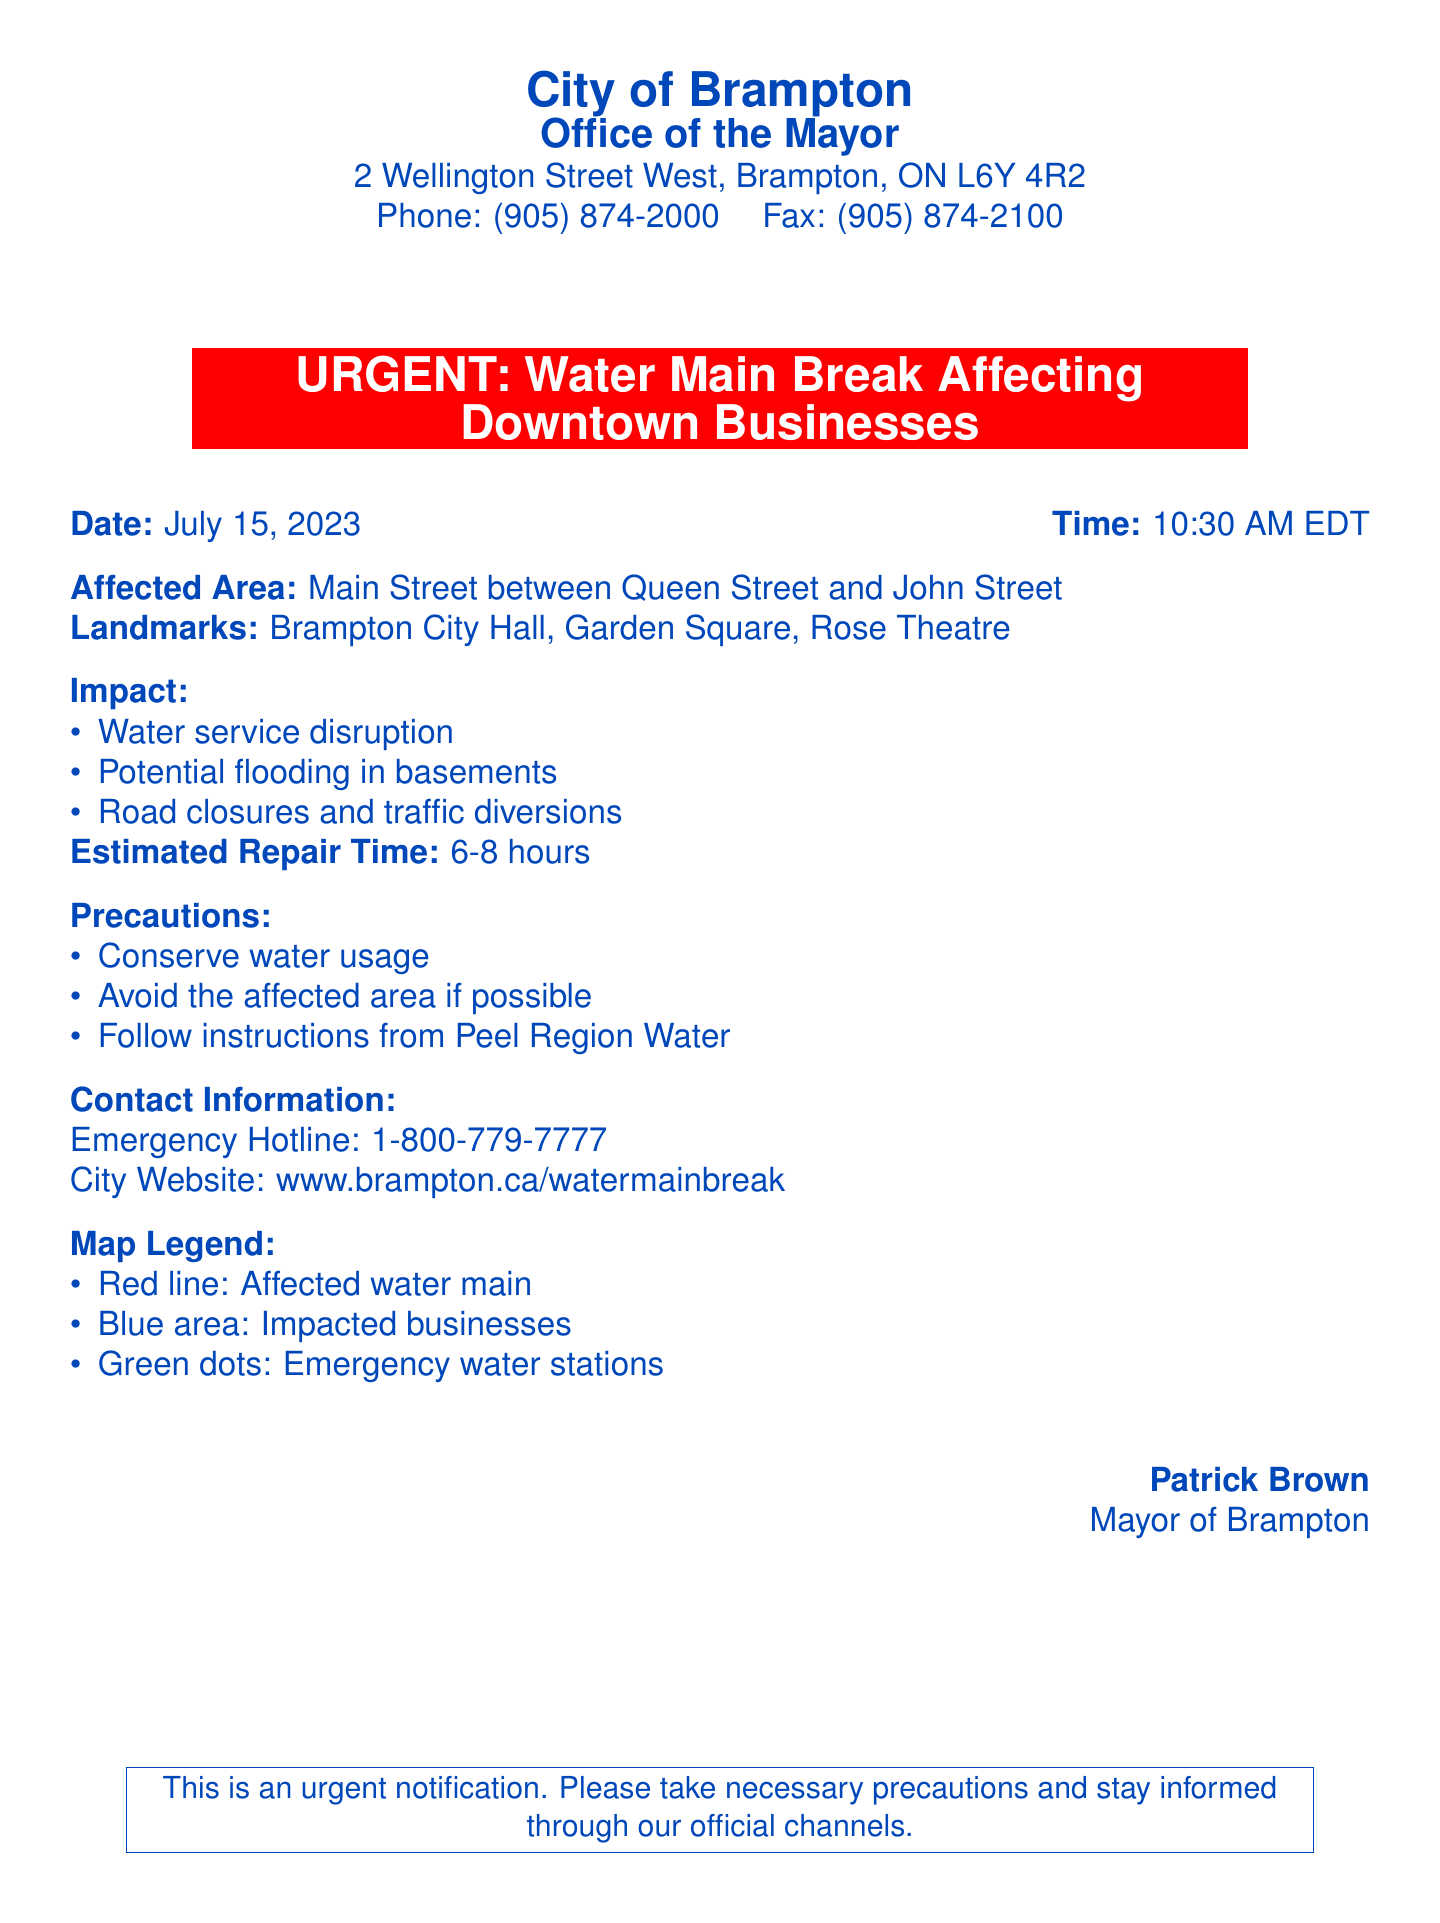What is the date of the water main break notification? The date is specified in the document as July 15, 2023.
Answer: July 15, 2023 What landmarks are mentioned in the affected area? The document lists Brampton City Hall, Garden Square, and Rose Theatre as landmarks.
Answer: Brampton City Hall, Garden Square, Rose Theatre What is the estimated repair time for the water main break? The estimated repair time is given in hours as 6-8 hours.
Answer: 6-8 hours What precautions should residents take? The document outlines precautions such as conserving water usage and avoiding the affected area.
Answer: Conserve water usage, avoid the affected area What is the emergency hotline number? The emergency hotline number is provided in the document for urgent inquiries related to the situation.
Answer: 1-800-779-7777 How will traffic be affected due to the water main break? The document states that there will be road closures and traffic diversions because of the break.
Answer: Road closures and traffic diversions Which area is primarily affected by the water main break? The affected area is described in the document as Main Street between Queen Street and John Street.
Answer: Main Street between Queen Street and John Street What color represents emergency water stations on the map? The document specifies that green dots represent emergency water stations on the map.
Answer: Green dots 